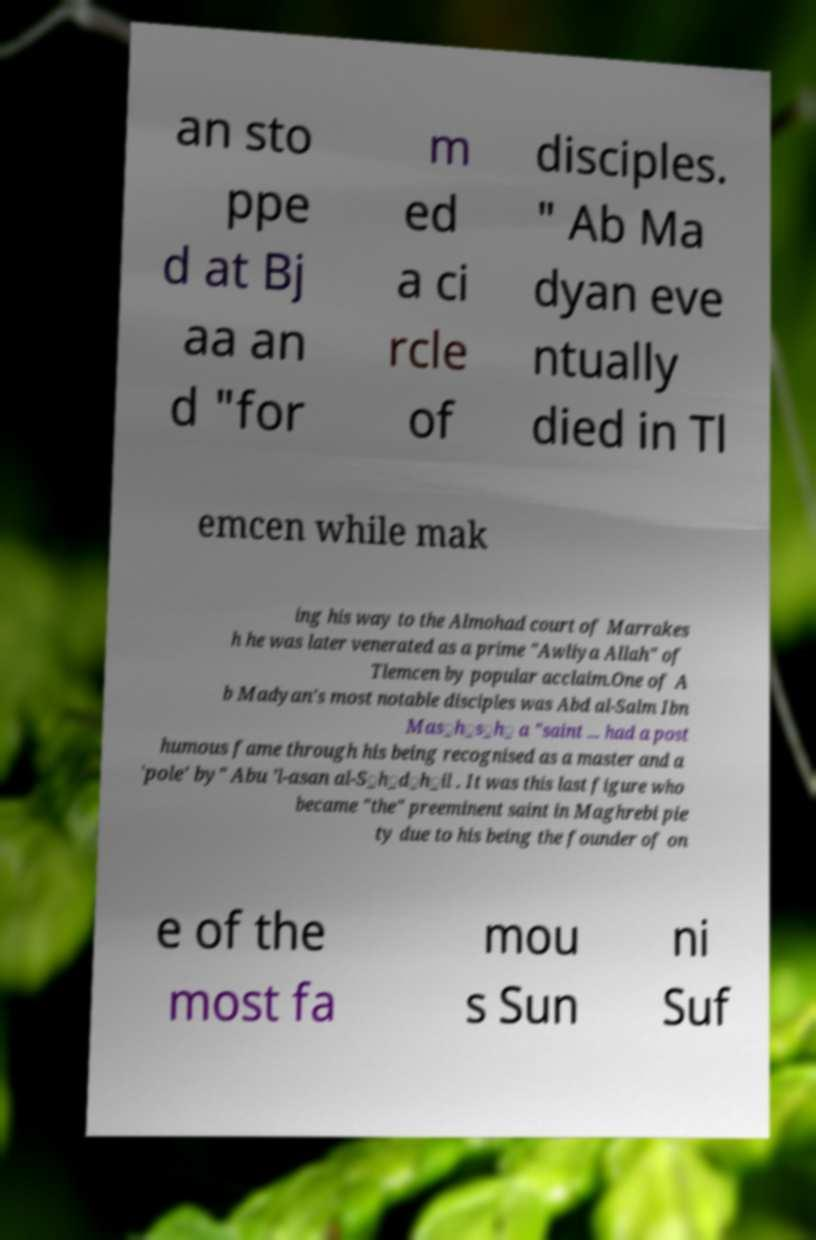What messages or text are displayed in this image? I need them in a readable, typed format. an sto ppe d at Bj aa an d "for m ed a ci rcle of disciples. " Ab Ma dyan eve ntually died in Tl emcen while mak ing his way to the Almohad court of Marrakes h he was later venerated as a prime "Awliya Allah" of Tlemcen by popular acclaim.One of A b Madyan's most notable disciples was Abd al-Salm Ibn Mas̲h̲s̲h̲ a "saint ... had a post humous fame through his being recognised as a master and a 'pole' by" Abu ’l-asan al-S̲h̲d̲h̲il . It was this last figure who became "the" preeminent saint in Maghrebi pie ty due to his being the founder of on e of the most fa mou s Sun ni Suf 